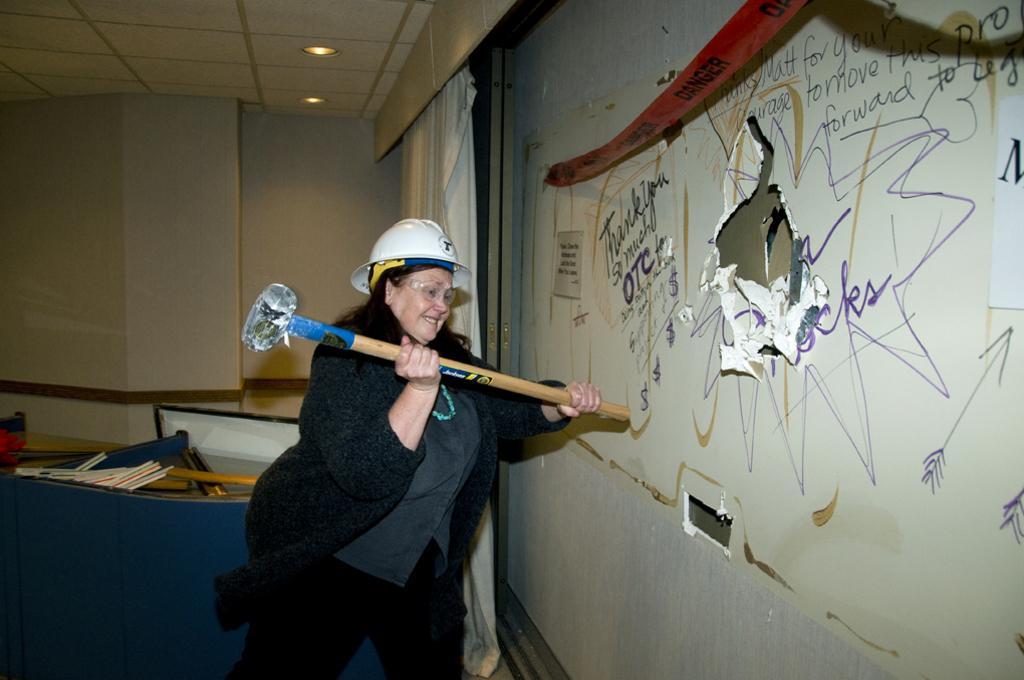Can you describe this image briefly? In this image I can see the person standing and holding the hammer. The person is wearing the black color dress and also white color hamlet. In-front of the person I can see the paper to the wall. To the left I can see the table and some objects in it. In the top I can see the lights and the ceiling. 